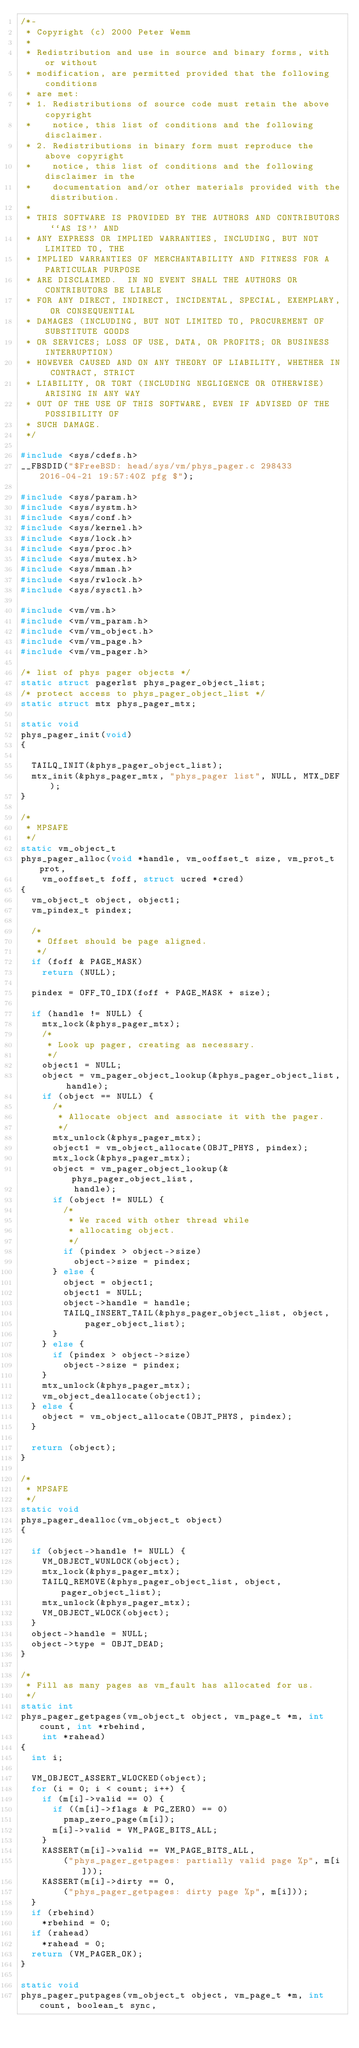Convert code to text. <code><loc_0><loc_0><loc_500><loc_500><_C_>/*-
 * Copyright (c) 2000 Peter Wemm
 *
 * Redistribution and use in source and binary forms, with or without
 * modification, are permitted provided that the following conditions
 * are met:
 * 1. Redistributions of source code must retain the above copyright
 *    notice, this list of conditions and the following disclaimer.
 * 2. Redistributions in binary form must reproduce the above copyright
 *    notice, this list of conditions and the following disclaimer in the
 *    documentation and/or other materials provided with the distribution.
 *
 * THIS SOFTWARE IS PROVIDED BY THE AUTHORS AND CONTRIBUTORS ``AS IS'' AND
 * ANY EXPRESS OR IMPLIED WARRANTIES, INCLUDING, BUT NOT LIMITED TO, THE
 * IMPLIED WARRANTIES OF MERCHANTABILITY AND FITNESS FOR A PARTICULAR PURPOSE
 * ARE DISCLAIMED.  IN NO EVENT SHALL THE AUTHORS OR CONTRIBUTORS BE LIABLE
 * FOR ANY DIRECT, INDIRECT, INCIDENTAL, SPECIAL, EXEMPLARY, OR CONSEQUENTIAL
 * DAMAGES (INCLUDING, BUT NOT LIMITED TO, PROCUREMENT OF SUBSTITUTE GOODS
 * OR SERVICES; LOSS OF USE, DATA, OR PROFITS; OR BUSINESS INTERRUPTION)
 * HOWEVER CAUSED AND ON ANY THEORY OF LIABILITY, WHETHER IN CONTRACT, STRICT
 * LIABILITY, OR TORT (INCLUDING NEGLIGENCE OR OTHERWISE) ARISING IN ANY WAY
 * OUT OF THE USE OF THIS SOFTWARE, EVEN IF ADVISED OF THE POSSIBILITY OF
 * SUCH DAMAGE.
 */

#include <sys/cdefs.h>
__FBSDID("$FreeBSD: head/sys/vm/phys_pager.c 298433 2016-04-21 19:57:40Z pfg $");

#include <sys/param.h>
#include <sys/systm.h>
#include <sys/conf.h>
#include <sys/kernel.h>
#include <sys/lock.h>
#include <sys/proc.h>
#include <sys/mutex.h>
#include <sys/mman.h>
#include <sys/rwlock.h>
#include <sys/sysctl.h>

#include <vm/vm.h>
#include <vm/vm_param.h>
#include <vm/vm_object.h>
#include <vm/vm_page.h>
#include <vm/vm_pager.h>

/* list of phys pager objects */
static struct pagerlst phys_pager_object_list;
/* protect access to phys_pager_object_list */
static struct mtx phys_pager_mtx;

static void
phys_pager_init(void)
{

	TAILQ_INIT(&phys_pager_object_list);
	mtx_init(&phys_pager_mtx, "phys_pager list", NULL, MTX_DEF);
}

/*
 * MPSAFE
 */
static vm_object_t
phys_pager_alloc(void *handle, vm_ooffset_t size, vm_prot_t prot,
    vm_ooffset_t foff, struct ucred *cred)
{
	vm_object_t object, object1;
	vm_pindex_t pindex;

	/*
	 * Offset should be page aligned.
	 */
	if (foff & PAGE_MASK)
		return (NULL);

	pindex = OFF_TO_IDX(foff + PAGE_MASK + size);

	if (handle != NULL) {
		mtx_lock(&phys_pager_mtx);
		/*
		 * Look up pager, creating as necessary.
		 */
		object1 = NULL;
		object = vm_pager_object_lookup(&phys_pager_object_list, handle);
		if (object == NULL) {
			/*
			 * Allocate object and associate it with the pager.
			 */
			mtx_unlock(&phys_pager_mtx);
			object1 = vm_object_allocate(OBJT_PHYS, pindex);
			mtx_lock(&phys_pager_mtx);
			object = vm_pager_object_lookup(&phys_pager_object_list,
			    handle);
			if (object != NULL) {
				/*
				 * We raced with other thread while
				 * allocating object.
				 */
				if (pindex > object->size)
					object->size = pindex;
			} else {
				object = object1;
				object1 = NULL;
				object->handle = handle;
				TAILQ_INSERT_TAIL(&phys_pager_object_list, object,
				    pager_object_list);
			}
		} else {
			if (pindex > object->size)
				object->size = pindex;
		}
		mtx_unlock(&phys_pager_mtx);
		vm_object_deallocate(object1);
	} else {
		object = vm_object_allocate(OBJT_PHYS, pindex);
	}

	return (object);
}

/*
 * MPSAFE
 */
static void
phys_pager_dealloc(vm_object_t object)
{

	if (object->handle != NULL) {
		VM_OBJECT_WUNLOCK(object);
		mtx_lock(&phys_pager_mtx);
		TAILQ_REMOVE(&phys_pager_object_list, object, pager_object_list);
		mtx_unlock(&phys_pager_mtx);
		VM_OBJECT_WLOCK(object);
	}
	object->handle = NULL;
	object->type = OBJT_DEAD;
}

/*
 * Fill as many pages as vm_fault has allocated for us.
 */
static int
phys_pager_getpages(vm_object_t object, vm_page_t *m, int count, int *rbehind,
    int *rahead)
{
	int i;

	VM_OBJECT_ASSERT_WLOCKED(object);
	for (i = 0; i < count; i++) {
		if (m[i]->valid == 0) {
			if ((m[i]->flags & PG_ZERO) == 0)
				pmap_zero_page(m[i]);
			m[i]->valid = VM_PAGE_BITS_ALL;
		}
		KASSERT(m[i]->valid == VM_PAGE_BITS_ALL,
		    ("phys_pager_getpages: partially valid page %p", m[i]));
		KASSERT(m[i]->dirty == 0,
		    ("phys_pager_getpages: dirty page %p", m[i]));
	}
	if (rbehind)
		*rbehind = 0;
	if (rahead)
		*rahead = 0;
	return (VM_PAGER_OK);
}

static void
phys_pager_putpages(vm_object_t object, vm_page_t *m, int count, boolean_t sync,</code> 